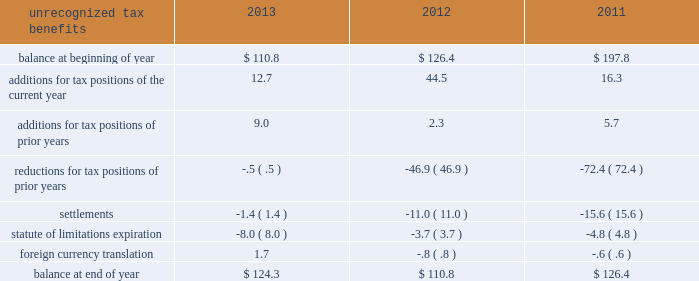Earnings were remitted as dividends after payment of all deferred taxes .
As more than 90% ( 90 % ) of the undistributed earnings are in countries with a statutory tax rate of 24% ( 24 % ) or higher , we do not generate a disproportionate amount of taxable income in countries with very low tax rates .
A reconciliation of the beginning and ending amount of the unrecognized tax benefits is as follows: .
At 30 september 2013 and 2012 , we had $ 124.3 and $ 110.8 of unrecognized tax benefits , excluding interest and penalties , of which $ 63.1 and $ 56.9 , respectively , would impact the effective tax rate if recognized .
Interest and penalties related to unrecognized tax benefits are recorded as a component of income tax expense and totaled $ 2.4 in 2013 , $ ( 26.1 ) in 2012 , and $ ( 2.4 ) in 2011 .
Our accrued balance for interest and penalties was $ 8.1 and $ 7.2 in 2013 and 2012 , respectively .
We were challenged by the spanish tax authorities over income tax deductions taken by certain of our spanish subsidiaries during fiscal years 2005 20132011 .
In november 2011 , we reached a settlement with the spanish tax authorities for 20ac41.3 million ( $ 56 ) in resolution of all tax issues under examination .
This settlement increased our income tax expense for the fiscal year ended 30 september 2012 by $ 43.8 ( $ .20 per share ) and had a 3.3% ( 3.3 % ) impact on our effective tax rate .
As a result of this settlement , we recorded a reduction in unrecognized tax benefits of $ 6.4 for tax positions taken in prior years and $ 11.0 for settlements .
On 25 january 2012 , the spanish supreme court released its decision in favor of our spanish subsidiary related to certain tax transactions for years 1991 and 1992 , a period before we controlled this subsidiary .
As a result , in the second quarter of 2012 , we recorded a reduction in income tax expense of $ 58.3 ( $ .27 per share ) , resulting in a 4.4% ( 4.4 % ) reduction in our effective tax rate for the fiscal year ended 30 september 2012 .
As a result of this ruling , we recorded a reduction in unrecognized tax benefits of $ 38.3 for tax positions taken in prior years .
During the third quarter of 2012 , our unrecognized tax benefits increased $ 33.3 as a result of certain tax positions taken in conjunction with the disposition of our homecare business .
When resolved , these benefits will be recognized in 201cincome from discontinued operations , net of tax 201d on our consolidated income statements and will not impact our effective tax rate .
For additional information , see note 3 , discontinued operations .
In the third quarter of 2011 , a u.s .
Internal revenue service audit over tax years 2007 and 2008 was completed , resulting in a decrease in unrecognized tax benefits of $ 36.0 and a favorable impact to earnings of $ 23.9 .
This included a tax benefit of $ 8.9 ( $ .04 per share ) recognized in income from discontinued operations for fiscal year 2011 , as it relates to the previously divested u.s .
Healthcare business .
We are also currently under examination in a number of tax jurisdictions , some of which may be resolved in the next twelve months .
As a result , it is reasonably possible that a change in the unrecognized tax benefits may occur during the next twelve months .
However , quantification of an estimated range cannot be made at this time. .
Considering the years 2011-2013 , what is the average value for settlements? 
Rationale: it is the sun of all settlements divided by three ( number of years ) .
Computations: table_average(settlements, none)
Answer: -9.33333. 